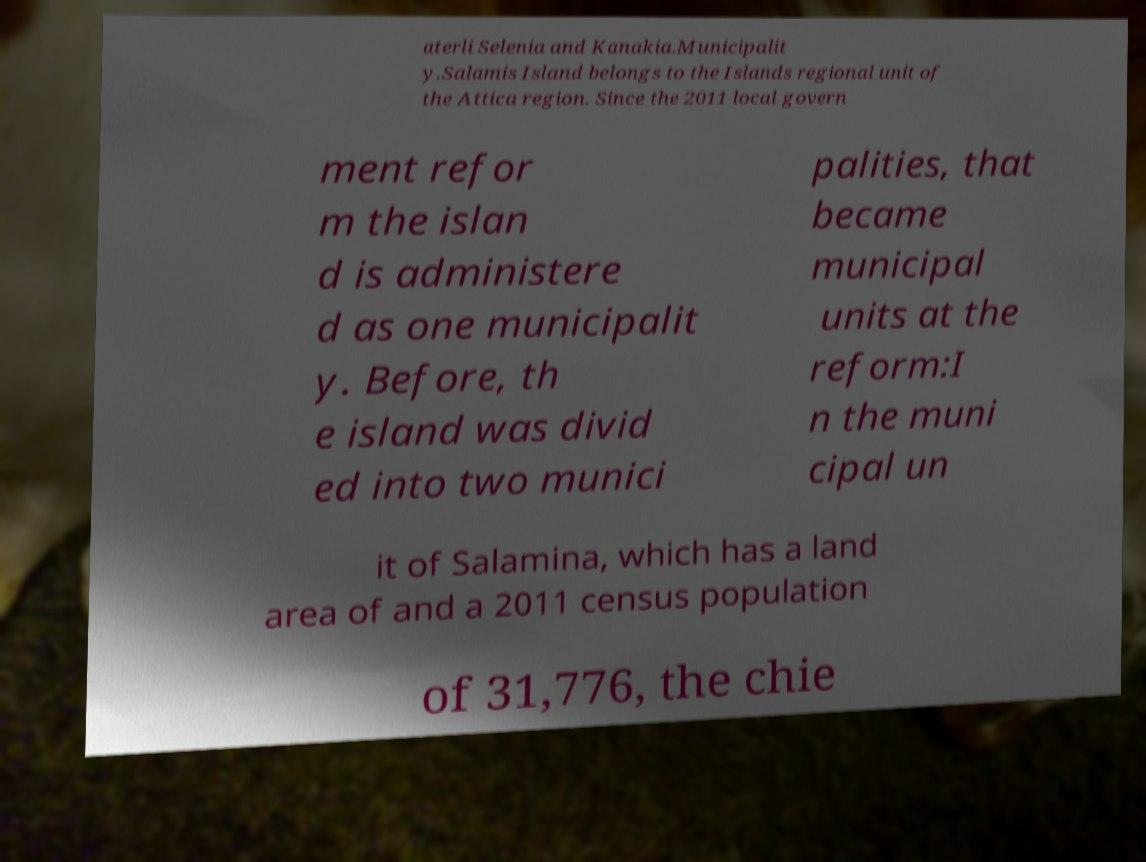Could you extract and type out the text from this image? aterli Selenia and Kanakia.Municipalit y.Salamis Island belongs to the Islands regional unit of the Attica region. Since the 2011 local govern ment refor m the islan d is administere d as one municipalit y. Before, th e island was divid ed into two munici palities, that became municipal units at the reform:I n the muni cipal un it of Salamina, which has a land area of and a 2011 census population of 31,776, the chie 